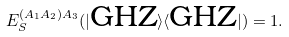<formula> <loc_0><loc_0><loc_500><loc_500>E _ { S } ^ { ( A _ { 1 } A _ { 2 } ) A _ { 3 } } ( | \text {GHZ} \rangle \langle \text {GHZ} | ) = 1 .</formula> 